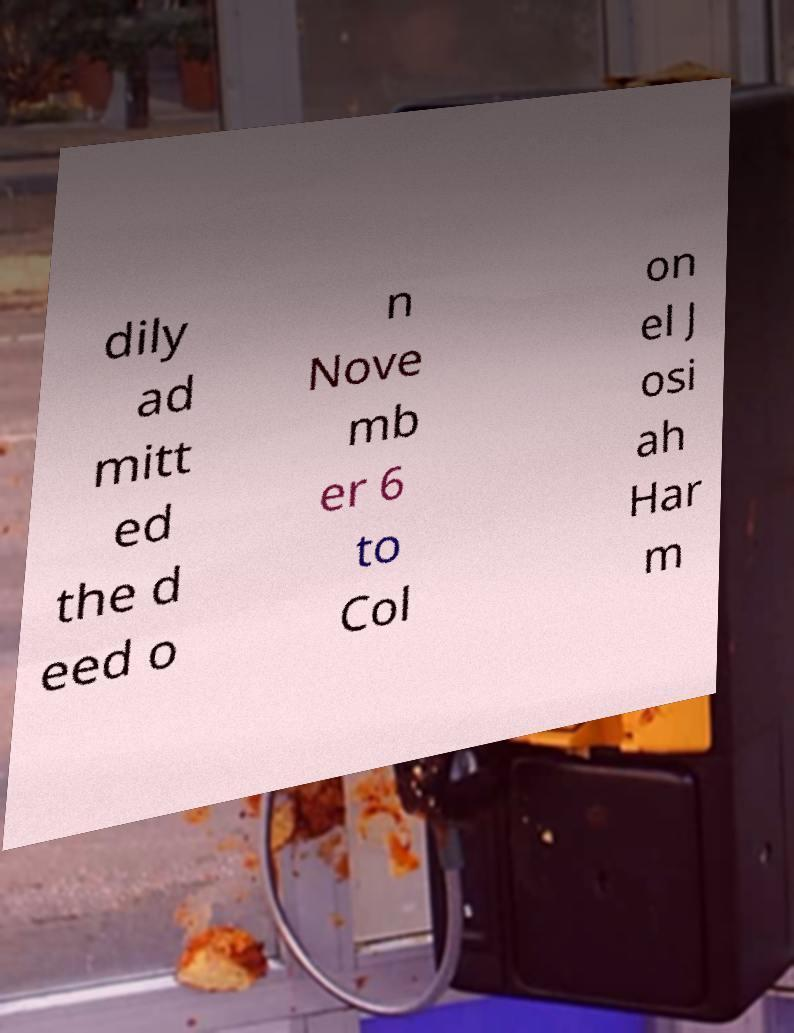What messages or text are displayed in this image? I need them in a readable, typed format. dily ad mitt ed the d eed o n Nove mb er 6 to Col on el J osi ah Har m 